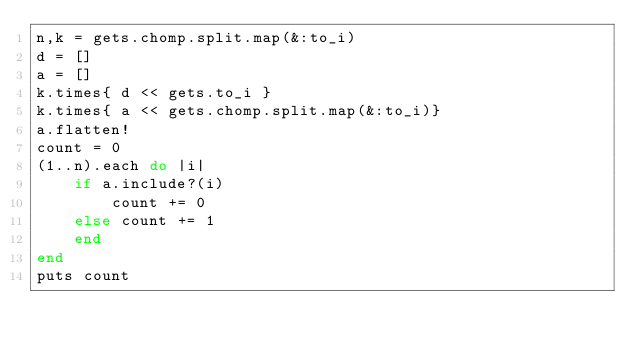Convert code to text. <code><loc_0><loc_0><loc_500><loc_500><_Ruby_>n,k = gets.chomp.split.map(&:to_i)
d = []
a = []
k.times{ d << gets.to_i }
k.times{ a << gets.chomp.split.map(&:to_i)}
a.flatten!
count = 0
(1..n).each do |i|
    if a.include?(i)
        count += 0
    else count += 1
    end
end
puts count</code> 